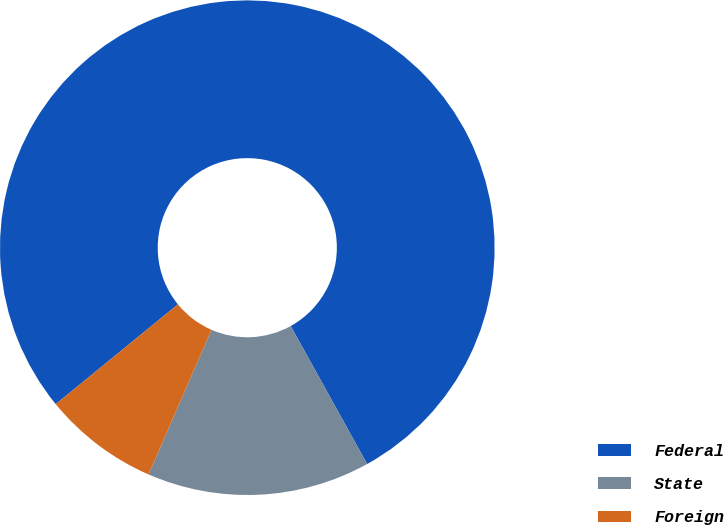Convert chart to OTSL. <chart><loc_0><loc_0><loc_500><loc_500><pie_chart><fcel>Federal<fcel>State<fcel>Foreign<nl><fcel>77.84%<fcel>14.59%<fcel>7.56%<nl></chart> 